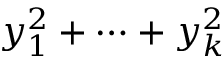<formula> <loc_0><loc_0><loc_500><loc_500>y _ { 1 } ^ { 2 } + \cdots + y _ { k } ^ { 2 }</formula> 